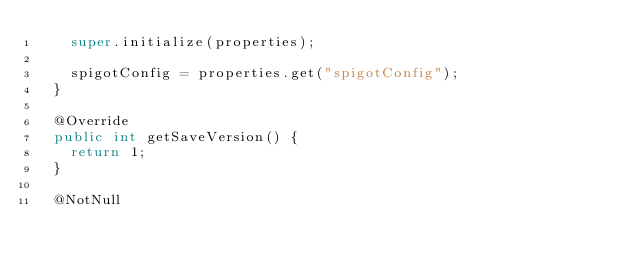<code> <loc_0><loc_0><loc_500><loc_500><_Java_>		super.initialize(properties);

		spigotConfig = properties.get("spigotConfig");
	}

	@Override
	public int getSaveVersion() {
		return 1;
	}

	@NotNull</code> 